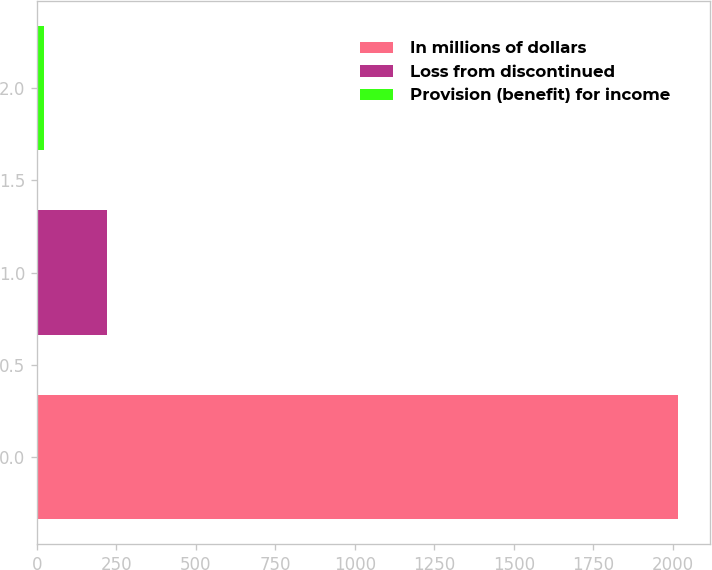Convert chart. <chart><loc_0><loc_0><loc_500><loc_500><bar_chart><fcel>In millions of dollars<fcel>Loss from discontinued<fcel>Provision (benefit) for income<nl><fcel>2016<fcel>221.4<fcel>22<nl></chart> 